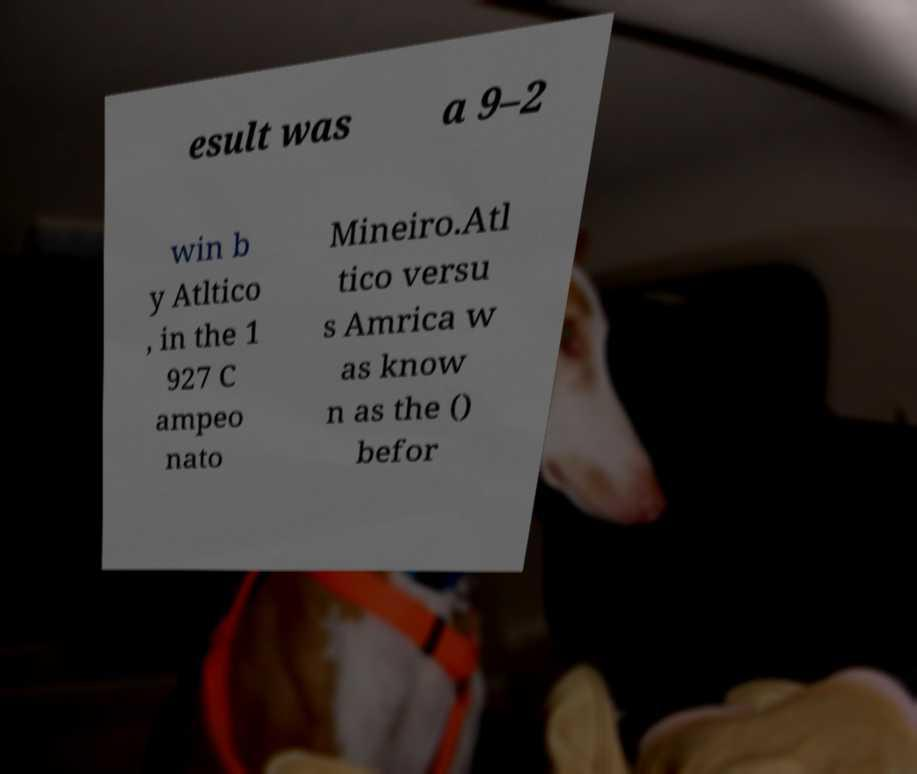Could you assist in decoding the text presented in this image and type it out clearly? esult was a 9–2 win b y Atltico , in the 1 927 C ampeo nato Mineiro.Atl tico versu s Amrica w as know n as the () befor 